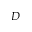Convert formula to latex. <formula><loc_0><loc_0><loc_500><loc_500>D</formula> 